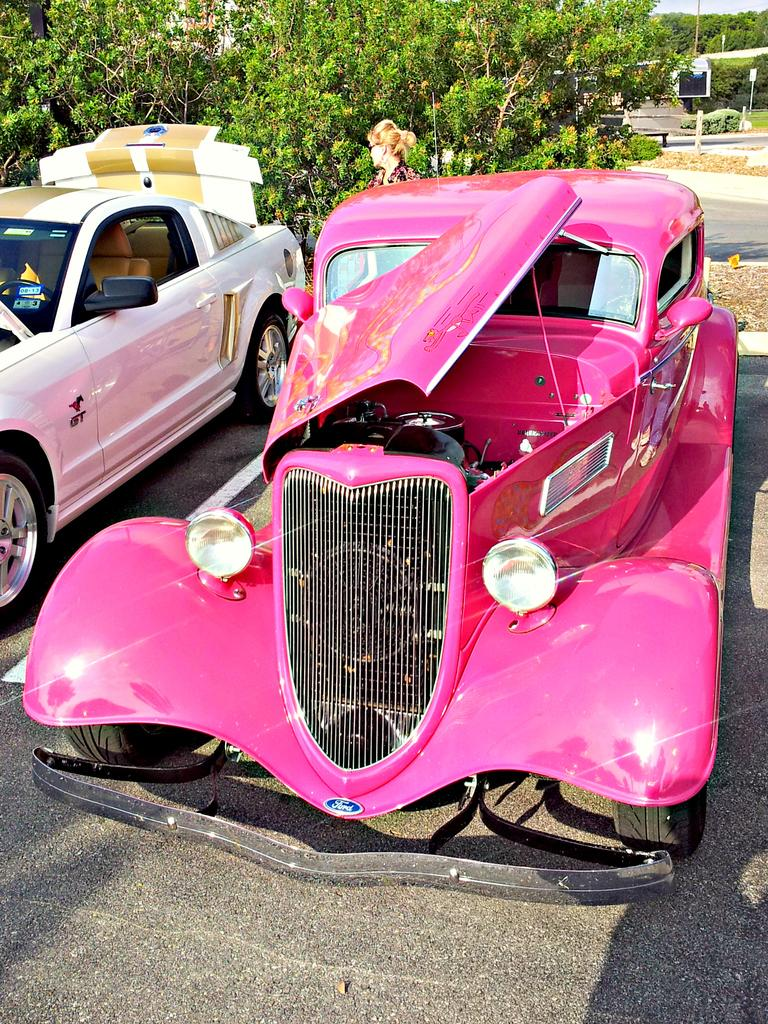What can be seen on the road in the image? There are two cars on the road in the image. What colors are the cars? One car is pink, and the other is white. Can you describe the person visible in the image? A woman is visible at the back of the cars. What is visible in the background of the image? There are many trees in the background of the image. What type of cable can be seen connecting the two cars in the image? There is no cable connecting the two cars in the image. What is the weather like in the image? The provided facts do not mention the weather, so we cannot determine the weather from the image. 